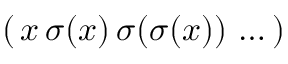<formula> <loc_0><loc_0><loc_500><loc_500>( \, x \, \sigma ( x ) \, \sigma ( \sigma ( x ) ) \, \dots \, )</formula> 